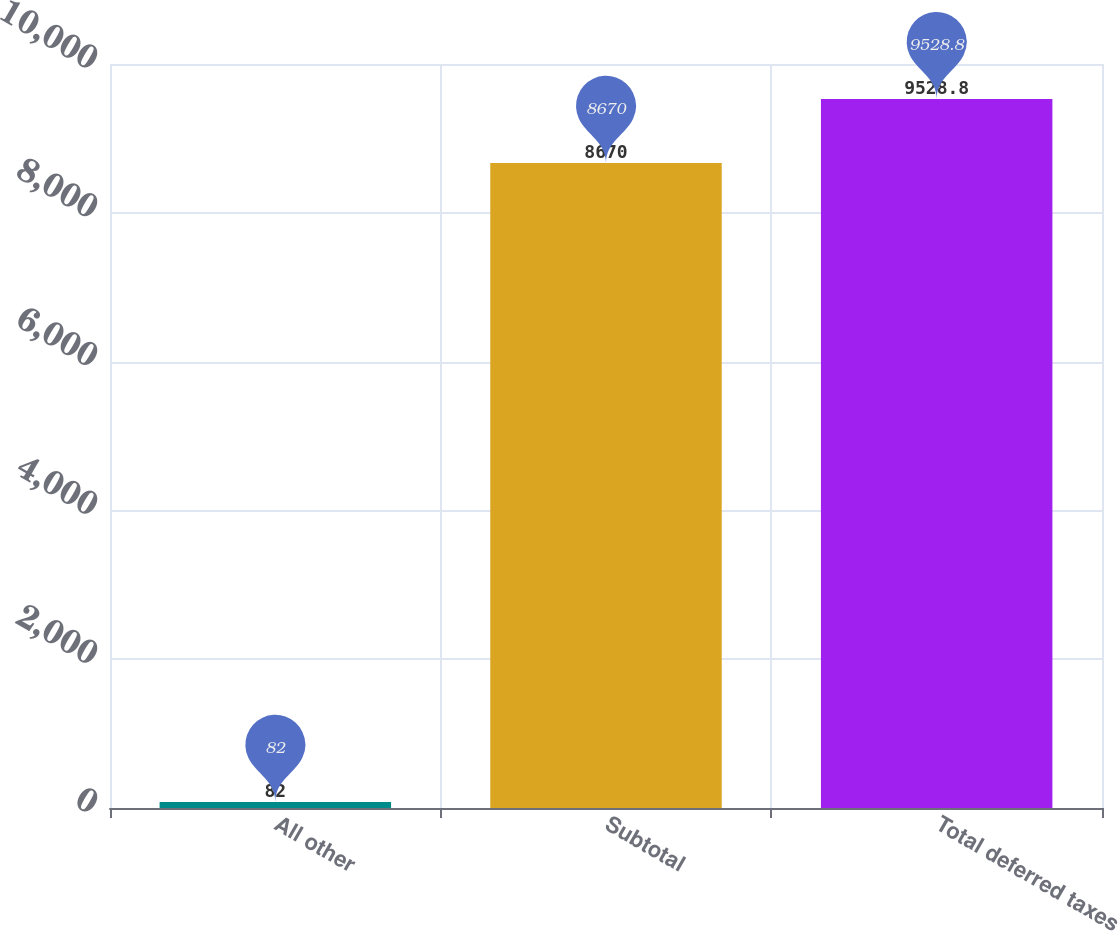Convert chart to OTSL. <chart><loc_0><loc_0><loc_500><loc_500><bar_chart><fcel>All other<fcel>Subtotal<fcel>Total deferred taxes<nl><fcel>82<fcel>8670<fcel>9528.8<nl></chart> 